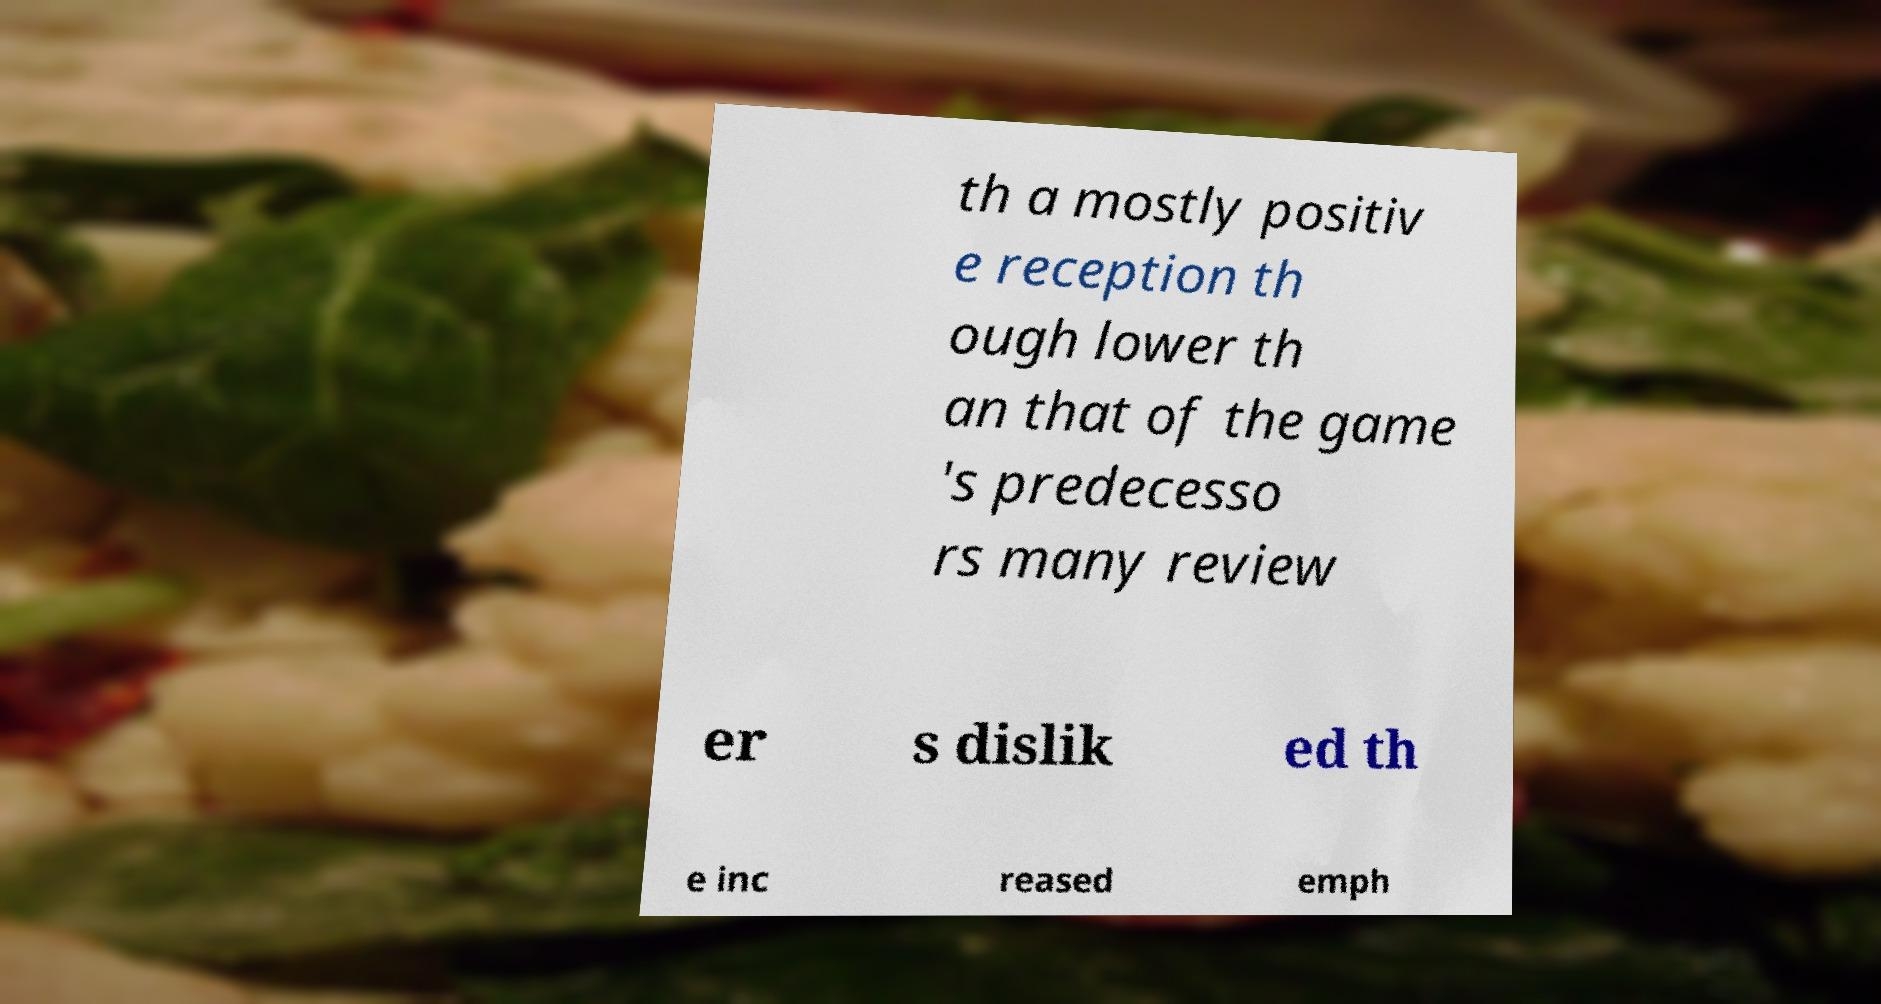There's text embedded in this image that I need extracted. Can you transcribe it verbatim? th a mostly positiv e reception th ough lower th an that of the game 's predecesso rs many review er s dislik ed th e inc reased emph 